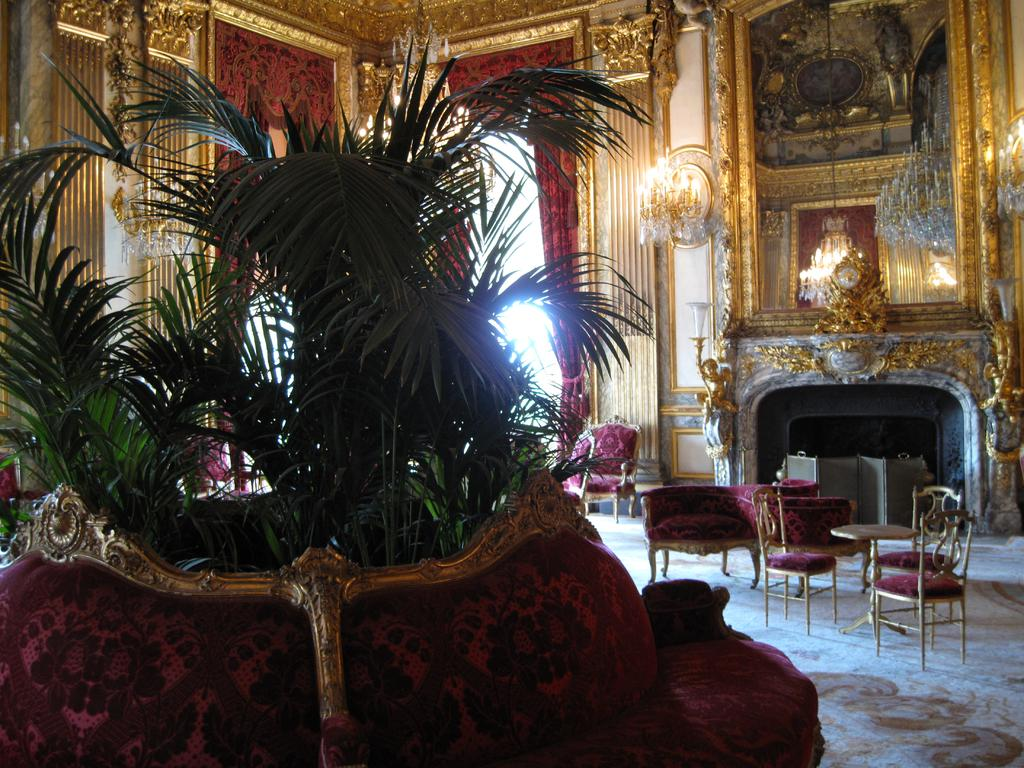What type of furniture is present in the image? There is a couch, chairs, and a table in the image. What kind of decorative element can be seen in the image? There is a plant in the image. What material is the wall made of in the image? The wall in the image is made of wood. How many ducks are sitting on the wooden wall in the image? There are no ducks present in the image; it only features a couch, chairs, table, plant, and wooden wall. 